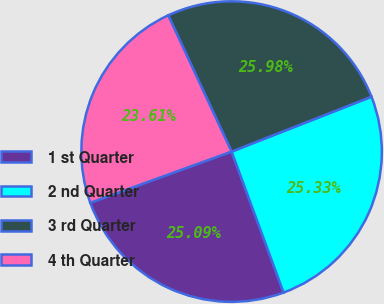Convert chart to OTSL. <chart><loc_0><loc_0><loc_500><loc_500><pie_chart><fcel>1 st Quarter<fcel>2 nd Quarter<fcel>3 rd Quarter<fcel>4 th Quarter<nl><fcel>25.09%<fcel>25.33%<fcel>25.98%<fcel>23.61%<nl></chart> 